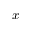<formula> <loc_0><loc_0><loc_500><loc_500>x</formula> 